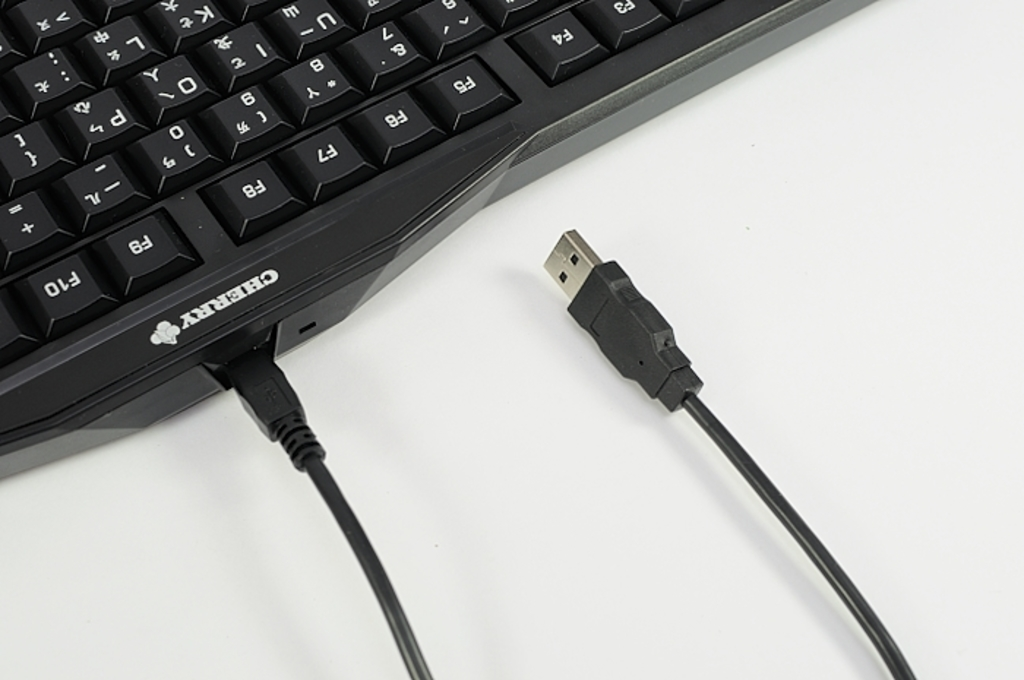Provide a one-sentence caption for the provided image. This image displays a black Cherry brand keyboard, easily identifiable by its logo, connected to a USB cable which is notable for its standard type-A connector. 